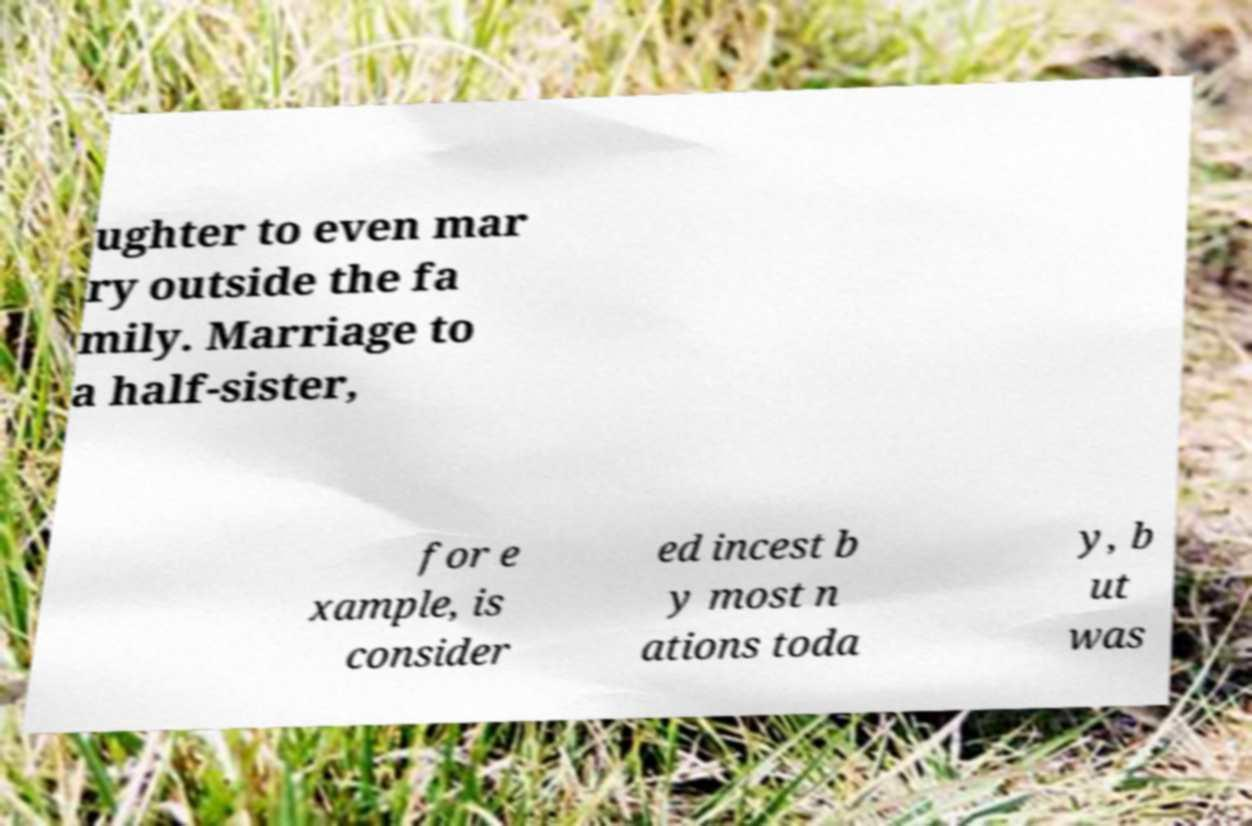Can you read and provide the text displayed in the image?This photo seems to have some interesting text. Can you extract and type it out for me? ughter to even mar ry outside the fa mily. Marriage to a half-sister, for e xample, is consider ed incest b y most n ations toda y, b ut was 